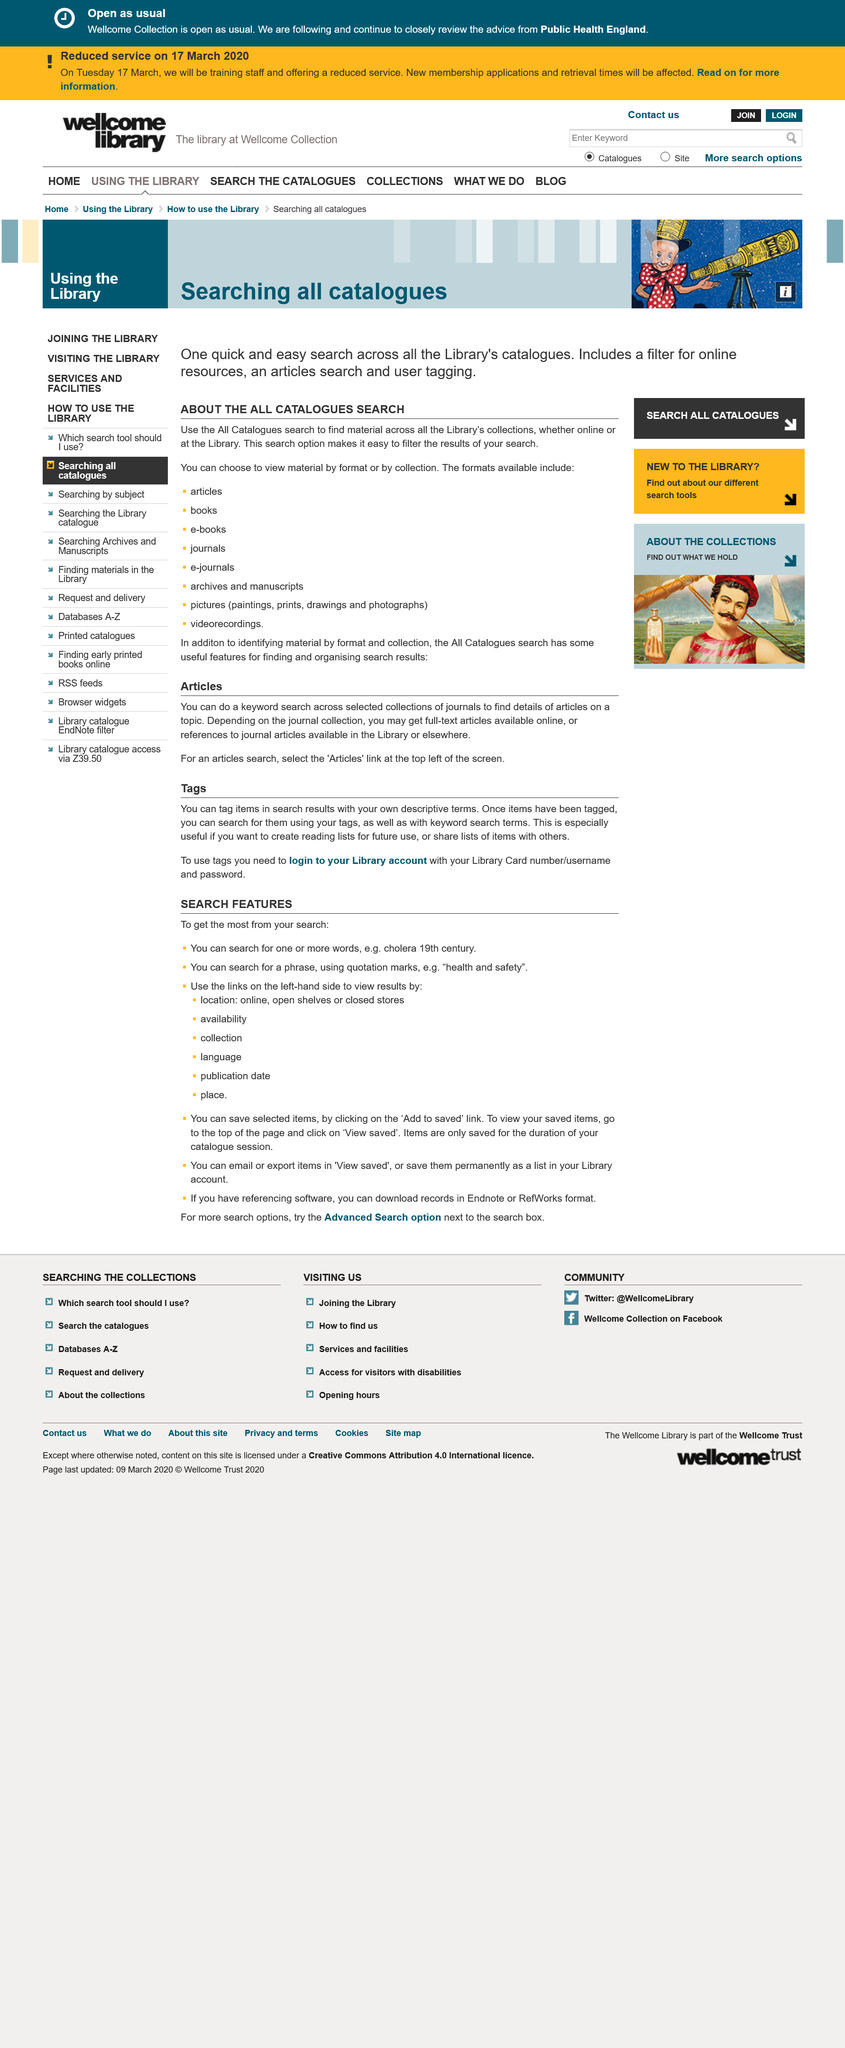Draw attention to some important aspects in this diagram. Yes, lists of items can be shared with others. Yes, full-text articles are available online. It is necessary to have a library account in order to use tags. Only users who are logged in can access tag words. 